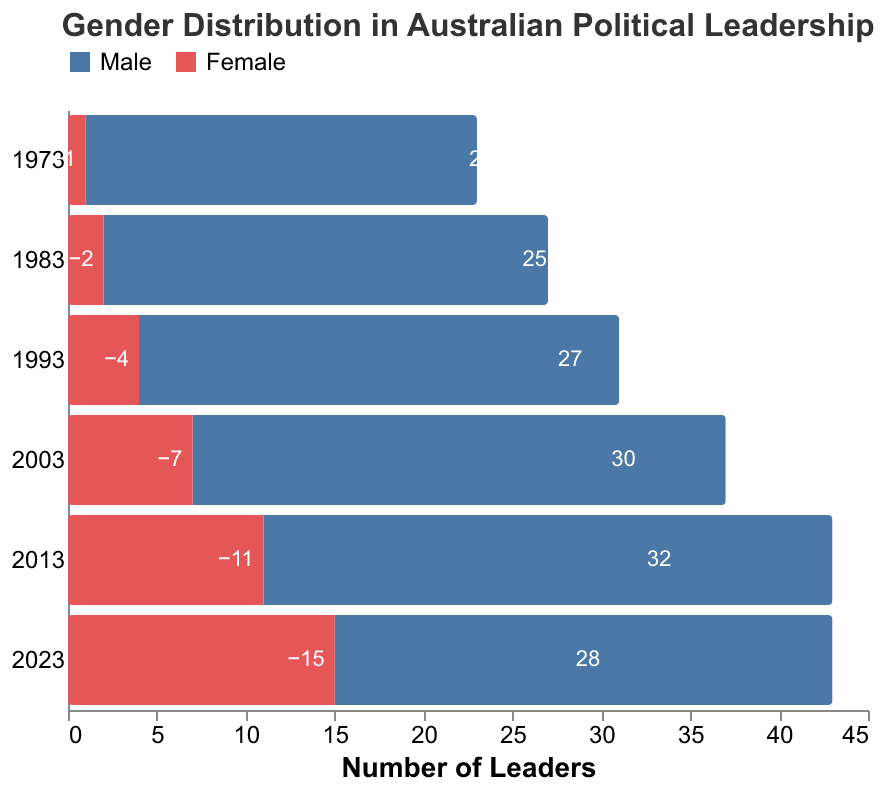What is the title of the figure? The title is displayed at the top of the figure, typically indicating the main focus of the plot.
Answer: Gender Distribution in Australian Political Leadership Which year has the highest number of male leaders? You can observe the length of the blue bars representing male leaders. The longest blue bar corresponds to 2013 with 32 male leaders.
Answer: 2013 What is the trend in the number of female leaders from 1973 to 2023? By comparing the lengths of the red bars for female leaders over the years, it is evident that the number of female leaders has been steadily increasing.
Answer: Increasing How many more male leaders were there than female leaders in 1993? Look at the values for male leaders (27) and female leaders (4) in 1993. Subtract the number of female leaders from the number of male leaders: 27 - 4 = 23.
Answer: 23 What is the difference in the number of female leaders between 1983 and 2023? Compare the values for female leaders in 1983 (2 leaders) and in 2023 (15 leaders). The difference is calculated as 15 - 2 = 13.
Answer: 13 In which year was the gap between male and female leaders the smallest? Calculate the difference between male and female leaders for each year and find the smallest value. For 1973 (21), 1983 (23), 1993 (23), 2003 (23), 2013 (21), 2023 (13). The smallest difference is in 2023.
Answer: 2023 How did the total number of leaders (male + female) change from 1973 to 2023? Sum the number of male and female leaders for 1973 (22 + 1 = 23) and for 2023 (28 + 15 = 43) and compare the totals. The total increased from 23 to 43.
Answer: Increased What is the average number of male leaders across all years shown? Sum the male leaders across all years and divide by the number of years: (22 + 25 + 27 + 30 + 32 + 28) / 6 = 27.33.
Answer: 27.33 